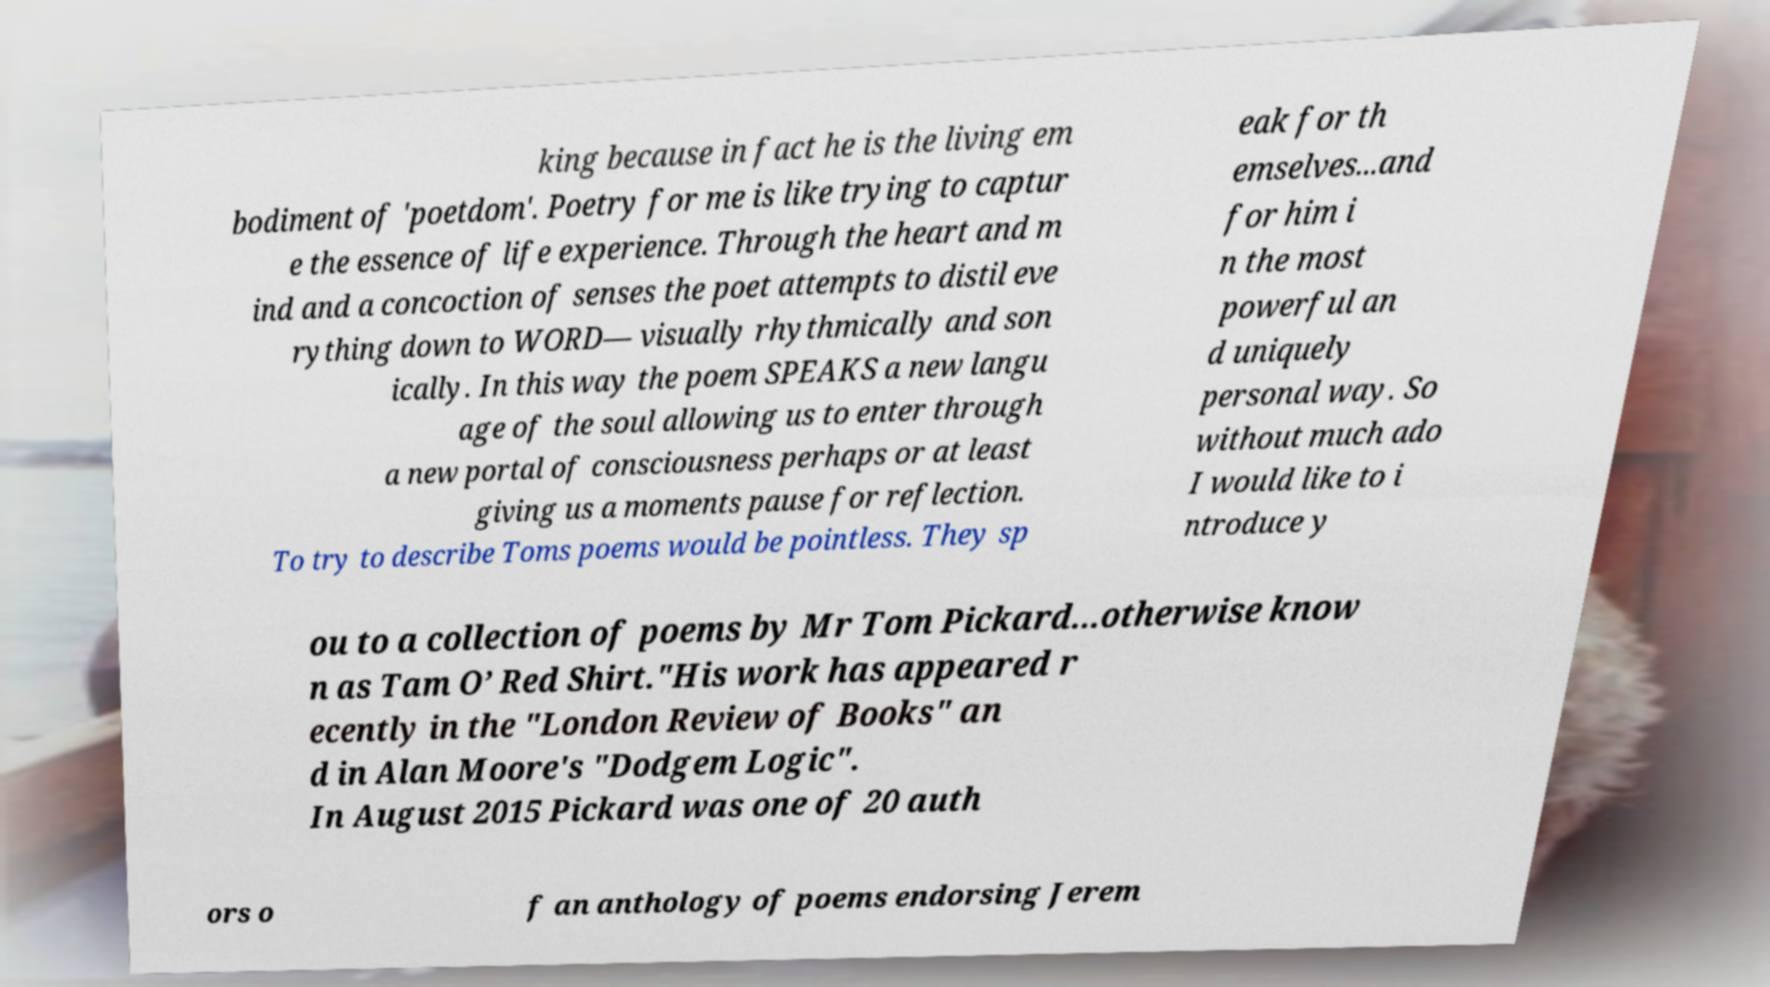Please read and relay the text visible in this image. What does it say? king because in fact he is the living em bodiment of 'poetdom'. Poetry for me is like trying to captur e the essence of life experience. Through the heart and m ind and a concoction of senses the poet attempts to distil eve rything down to WORD— visually rhythmically and son ically. In this way the poem SPEAKS a new langu age of the soul allowing us to enter through a new portal of consciousness perhaps or at least giving us a moments pause for reflection. To try to describe Toms poems would be pointless. They sp eak for th emselves...and for him i n the most powerful an d uniquely personal way. So without much ado I would like to i ntroduce y ou to a collection of poems by Mr Tom Pickard...otherwise know n as Tam O’ Red Shirt."His work has appeared r ecently in the "London Review of Books" an d in Alan Moore's "Dodgem Logic". In August 2015 Pickard was one of 20 auth ors o f an anthology of poems endorsing Jerem 